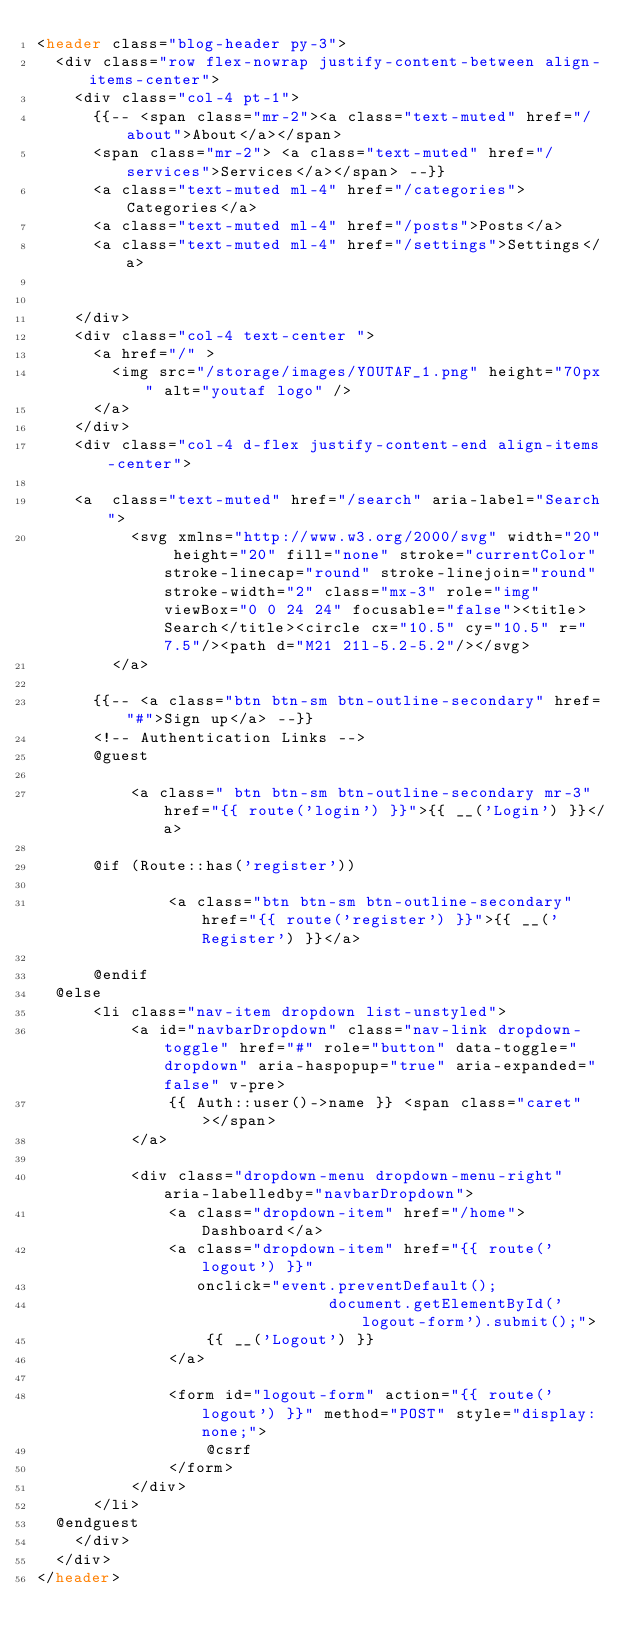<code> <loc_0><loc_0><loc_500><loc_500><_PHP_><header class="blog-header py-3">
  <div class="row flex-nowrap justify-content-between align-items-center">
    <div class="col-4 pt-1">
      {{-- <span class="mr-2"><a class="text-muted" href="/about">About</a></span>
      <span class="mr-2"> <a class="text-muted" href="/services">Services</a></span> --}}
      <a class="text-muted ml-4" href="/categories">Categories</a>
      <a class="text-muted ml-4" href="/posts">Posts</a>
      <a class="text-muted ml-4" href="/settings">Settings</a>


    </div>
    <div class="col-4 text-center ">
      <a href="/" >
        <img src="/storage/images/YOUTAF_1.png" height="70px" alt="youtaf logo" />
      </a>
    </div>
    <div class="col-4 d-flex justify-content-end align-items-center">
     
    <a  class="text-muted" href="/search" aria-label="Search">
          <svg xmlns="http://www.w3.org/2000/svg" width="20" height="20" fill="none" stroke="currentColor" stroke-linecap="round" stroke-linejoin="round" stroke-width="2" class="mx-3" role="img" viewBox="0 0 24 24" focusable="false"><title>Search</title><circle cx="10.5" cy="10.5" r="7.5"/><path d="M21 21l-5.2-5.2"/></svg>
        </a>

      {{-- <a class="btn btn-sm btn-outline-secondary" href="#">Sign up</a> --}}
      <!-- Authentication Links -->
      @guest
     
          <a class=" btn btn-sm btn-outline-secondary mr-3" href="{{ route('login') }}">{{ __('Login') }}</a>
     
      @if (Route::has('register'))
         
              <a class="btn btn-sm btn-outline-secondary" href="{{ route('register') }}">{{ __('Register') }}</a>
         
      @endif
  @else
      <li class="nav-item dropdown list-unstyled">
          <a id="navbarDropdown" class="nav-link dropdown-toggle" href="#" role="button" data-toggle="dropdown" aria-haspopup="true" aria-expanded="false" v-pre>
              {{ Auth::user()->name }} <span class="caret"></span>
          </a>

          <div class="dropdown-menu dropdown-menu-right" aria-labelledby="navbarDropdown">
              <a class="dropdown-item" href="/home">Dashboard</a>
              <a class="dropdown-item" href="{{ route('logout') }}"
                 onclick="event.preventDefault();
                               document.getElementById('logout-form').submit();">
                  {{ __('Logout') }}
              </a>

              <form id="logout-form" action="{{ route('logout') }}" method="POST" style="display: none;">
                  @csrf
              </form>
          </div>
      </li>
  @endguest
    </div>
  </div>
</header>
</code> 